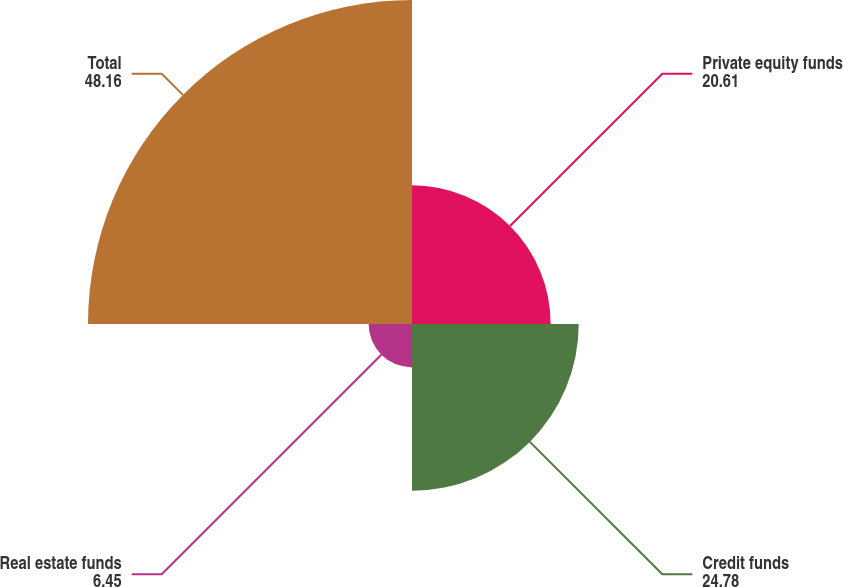<chart> <loc_0><loc_0><loc_500><loc_500><pie_chart><fcel>Private equity funds<fcel>Credit funds<fcel>Real estate funds<fcel>Total<nl><fcel>20.61%<fcel>24.78%<fcel>6.45%<fcel>48.16%<nl></chart> 